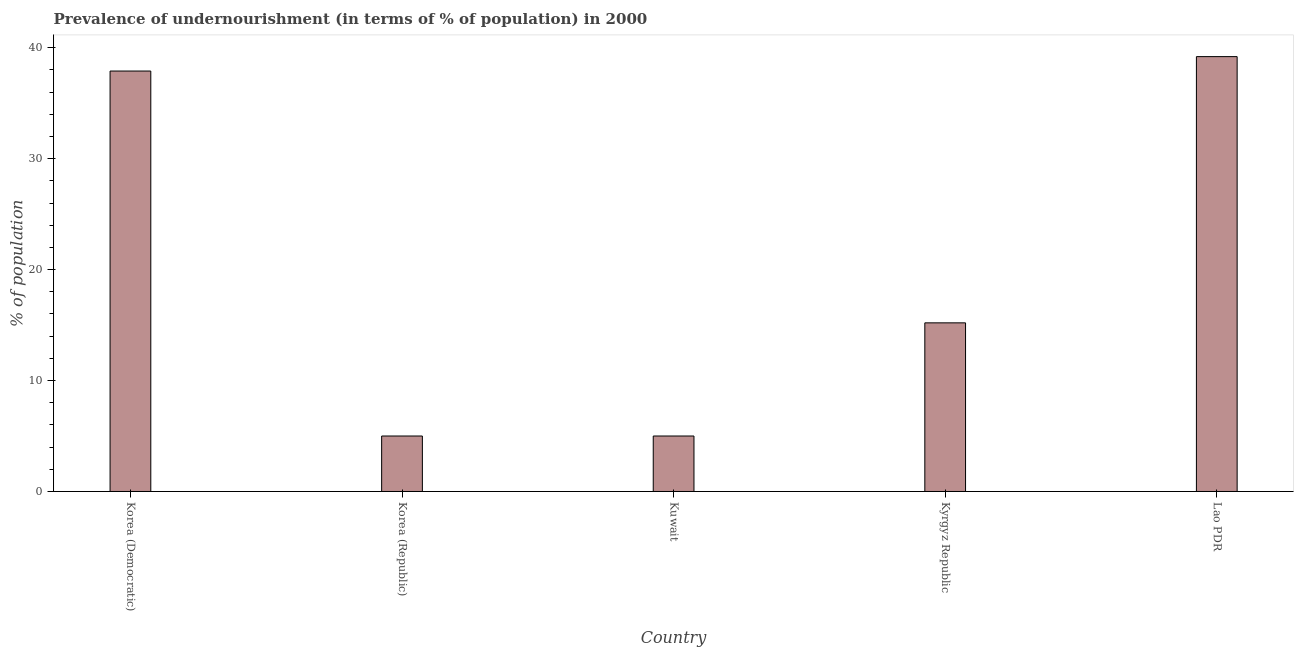Does the graph contain any zero values?
Provide a short and direct response. No. What is the title of the graph?
Your answer should be very brief. Prevalence of undernourishment (in terms of % of population) in 2000. What is the label or title of the Y-axis?
Offer a very short reply. % of population. Across all countries, what is the maximum percentage of undernourished population?
Offer a very short reply. 39.2. In which country was the percentage of undernourished population maximum?
Provide a short and direct response. Lao PDR. What is the sum of the percentage of undernourished population?
Offer a very short reply. 102.3. What is the average percentage of undernourished population per country?
Your answer should be compact. 20.46. What is the median percentage of undernourished population?
Keep it short and to the point. 15.2. In how many countries, is the percentage of undernourished population greater than 32 %?
Your answer should be very brief. 2. What is the ratio of the percentage of undernourished population in Korea (Democratic) to that in Kuwait?
Provide a succinct answer. 7.58. Is the percentage of undernourished population in Korea (Democratic) less than that in Korea (Republic)?
Your answer should be compact. No. What is the difference between the highest and the lowest percentage of undernourished population?
Keep it short and to the point. 34.2. Are all the bars in the graph horizontal?
Provide a short and direct response. No. How many countries are there in the graph?
Ensure brevity in your answer.  5. What is the difference between two consecutive major ticks on the Y-axis?
Offer a very short reply. 10. Are the values on the major ticks of Y-axis written in scientific E-notation?
Offer a very short reply. No. What is the % of population of Korea (Democratic)?
Provide a succinct answer. 37.9. What is the % of population in Kuwait?
Provide a short and direct response. 5. What is the % of population in Lao PDR?
Give a very brief answer. 39.2. What is the difference between the % of population in Korea (Democratic) and Korea (Republic)?
Provide a short and direct response. 32.9. What is the difference between the % of population in Korea (Democratic) and Kuwait?
Your answer should be very brief. 32.9. What is the difference between the % of population in Korea (Democratic) and Kyrgyz Republic?
Give a very brief answer. 22.7. What is the difference between the % of population in Korea (Democratic) and Lao PDR?
Provide a short and direct response. -1.3. What is the difference between the % of population in Korea (Republic) and Lao PDR?
Your answer should be compact. -34.2. What is the difference between the % of population in Kuwait and Lao PDR?
Make the answer very short. -34.2. What is the difference between the % of population in Kyrgyz Republic and Lao PDR?
Make the answer very short. -24. What is the ratio of the % of population in Korea (Democratic) to that in Korea (Republic)?
Provide a succinct answer. 7.58. What is the ratio of the % of population in Korea (Democratic) to that in Kuwait?
Provide a succinct answer. 7.58. What is the ratio of the % of population in Korea (Democratic) to that in Kyrgyz Republic?
Provide a succinct answer. 2.49. What is the ratio of the % of population in Korea (Republic) to that in Kuwait?
Provide a short and direct response. 1. What is the ratio of the % of population in Korea (Republic) to that in Kyrgyz Republic?
Provide a succinct answer. 0.33. What is the ratio of the % of population in Korea (Republic) to that in Lao PDR?
Provide a succinct answer. 0.13. What is the ratio of the % of population in Kuwait to that in Kyrgyz Republic?
Offer a very short reply. 0.33. What is the ratio of the % of population in Kuwait to that in Lao PDR?
Ensure brevity in your answer.  0.13. What is the ratio of the % of population in Kyrgyz Republic to that in Lao PDR?
Your answer should be compact. 0.39. 